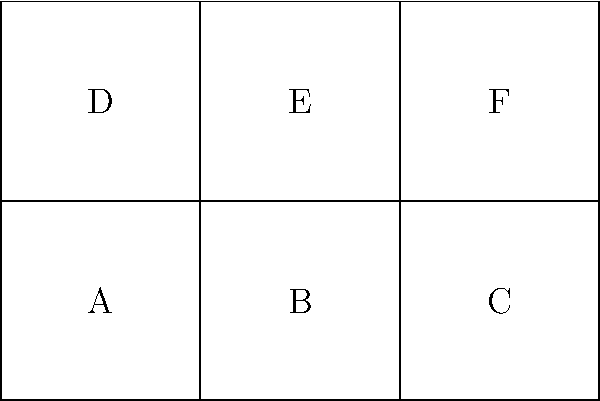The image shows an unfolded pattern of a cube. Each face is labeled with a letter. If the pattern is folded to form a cube, which face will be opposite to face A? To determine which face is opposite to face A when the cube is folded, let's follow these steps:

1. Visualize the folding process:
   - Faces B and C will fold upwards to form the right and back faces of the cube.
   - Faces D, E, and F will fold upwards to form the left, top, and front faces of the cube.

2. Identify the position of face A:
   - Face A will become the bottom face of the cube.

3. Determine the opposite face:
   - In a cube, opposite faces are those that are parallel and furthest apart.
   - The face that will be parallel to and furthest from the bottom face (A) will be the top face.

4. Identify the top face:
   - When folded, face E will be on top of the cube, directly above face A.

Therefore, face E will be opposite to face A when the pattern is folded into a cube.
Answer: E 